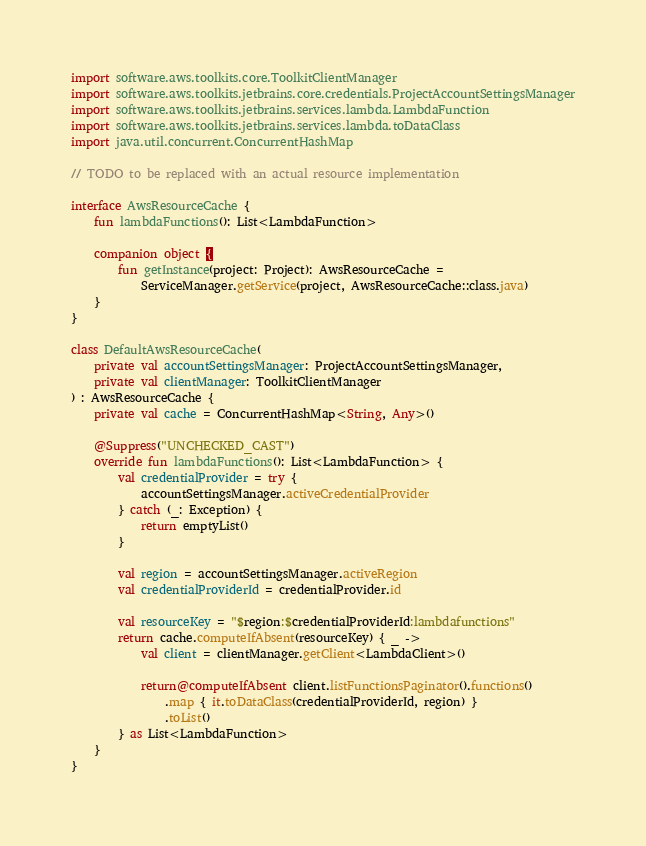Convert code to text. <code><loc_0><loc_0><loc_500><loc_500><_Kotlin_>import software.aws.toolkits.core.ToolkitClientManager
import software.aws.toolkits.jetbrains.core.credentials.ProjectAccountSettingsManager
import software.aws.toolkits.jetbrains.services.lambda.LambdaFunction
import software.aws.toolkits.jetbrains.services.lambda.toDataClass
import java.util.concurrent.ConcurrentHashMap

// TODO to be replaced with an actual resource implementation

interface AwsResourceCache {
    fun lambdaFunctions(): List<LambdaFunction>

    companion object {
        fun getInstance(project: Project): AwsResourceCache =
            ServiceManager.getService(project, AwsResourceCache::class.java)
    }
}

class DefaultAwsResourceCache(
    private val accountSettingsManager: ProjectAccountSettingsManager,
    private val clientManager: ToolkitClientManager
) : AwsResourceCache {
    private val cache = ConcurrentHashMap<String, Any>()

    @Suppress("UNCHECKED_CAST")
    override fun lambdaFunctions(): List<LambdaFunction> {
        val credentialProvider = try {
            accountSettingsManager.activeCredentialProvider
        } catch (_: Exception) {
            return emptyList()
        }

        val region = accountSettingsManager.activeRegion
        val credentialProviderId = credentialProvider.id

        val resourceKey = "$region:$credentialProviderId:lambdafunctions"
        return cache.computeIfAbsent(resourceKey) { _ ->
            val client = clientManager.getClient<LambdaClient>()

            return@computeIfAbsent client.listFunctionsPaginator().functions()
                .map { it.toDataClass(credentialProviderId, region) }
                .toList()
        } as List<LambdaFunction>
    }
}
</code> 